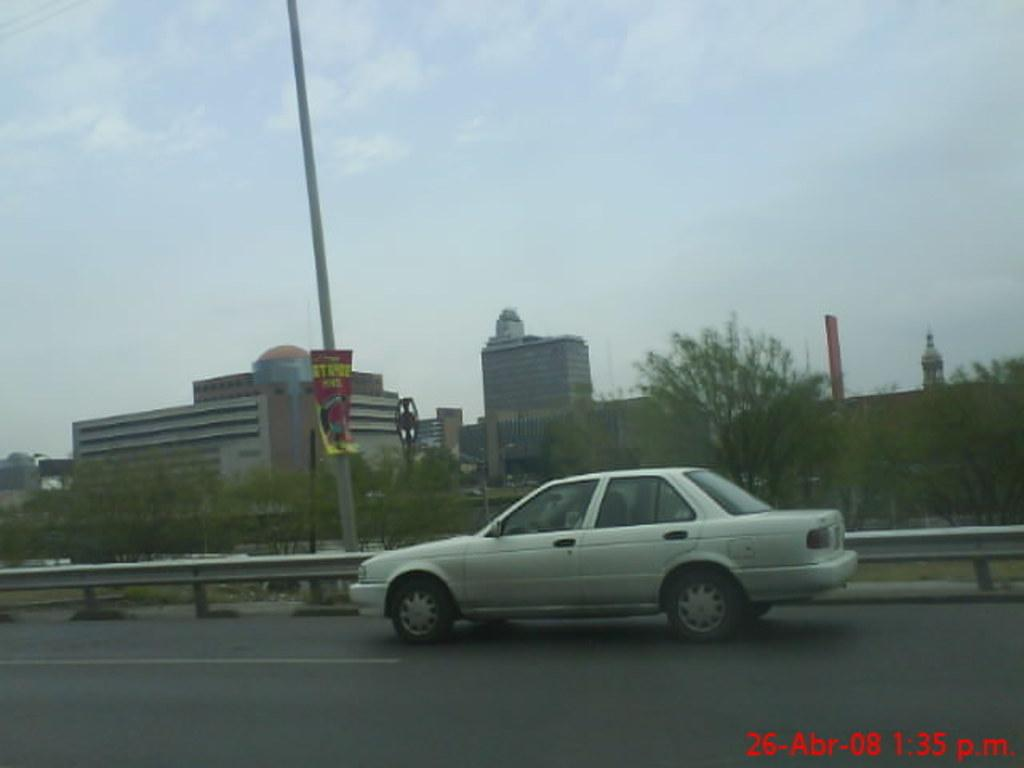What is the main feature of the image? There is a road in the image. What is on the road? There is a car on the road. What can be seen in the background of the image? There are buildings and trees in the background of the image. What else is present in the image? There is a pole in the image. What is visible at the top of the image? The sky is visible at the top of the image. What type of steel is used to construct the toad in the image? There is no toad or steel present in the image. How many blades can be seen on the car in the image? There are no blades visible on the car in the image. 